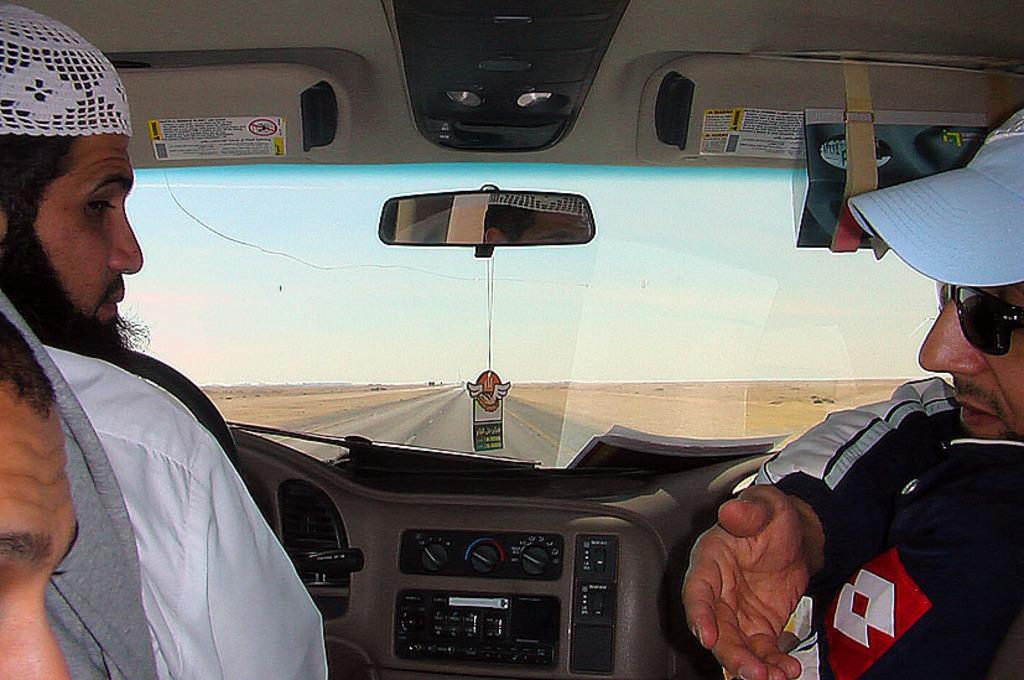How many people are inside the car in the image? There are three persons in the car. What are the persons doing in the car? The persons are sitting inside the car. What part of the car can be seen in the image? The car window is visible. What is visible through the car window? There is a road and the sky visible through the car window. Where is the bedroom located in the image? There is no bedroom present in the image; it features a car with three persons inside. Can you see any icicles hanging from the car window in the image? There are no icicles visible in the image. 